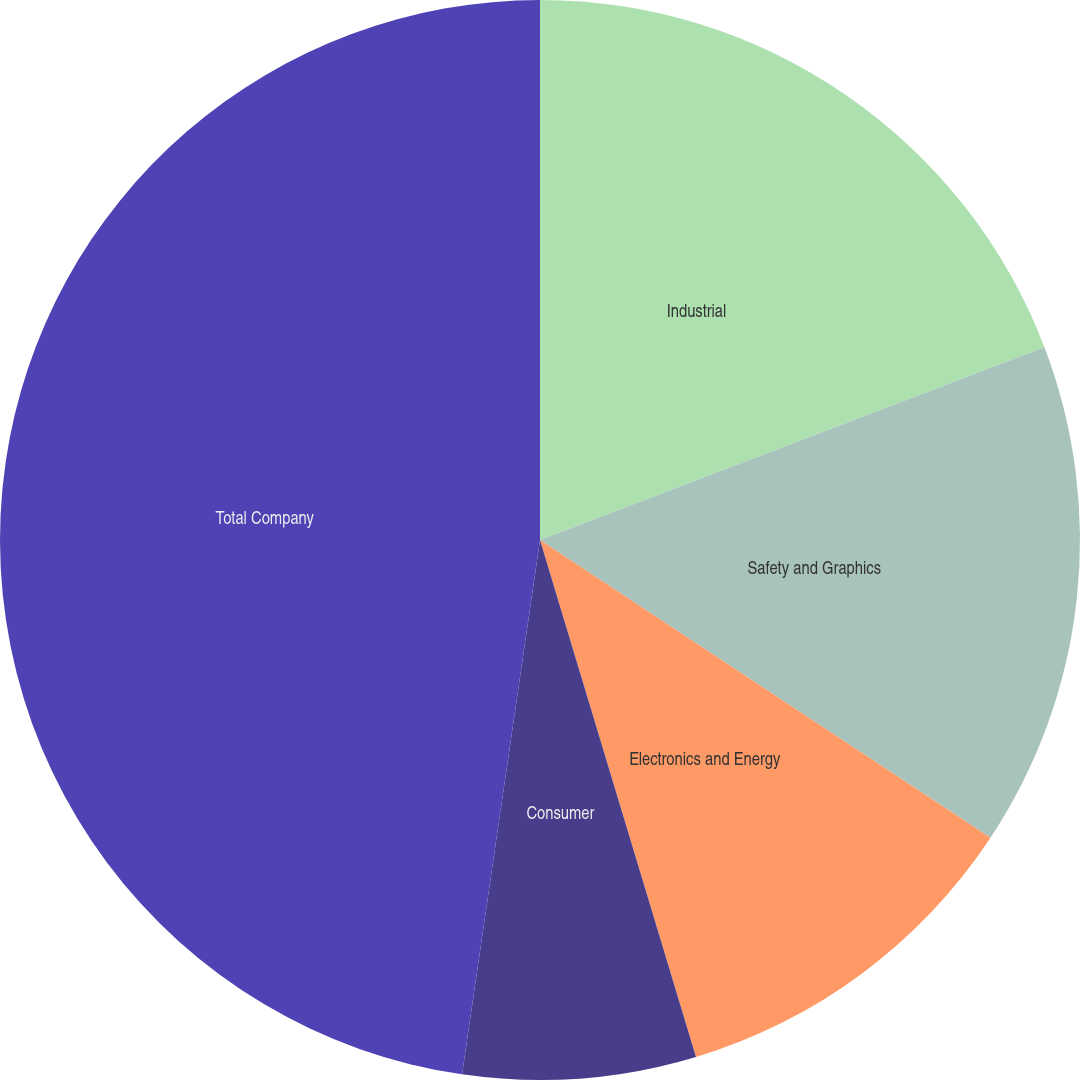<chart> <loc_0><loc_0><loc_500><loc_500><pie_chart><fcel>Industrial<fcel>Safety and Graphics<fcel>Electronics and Energy<fcel>Consumer<fcel>Total Company<nl><fcel>19.19%<fcel>15.11%<fcel>11.04%<fcel>6.97%<fcel>47.7%<nl></chart> 